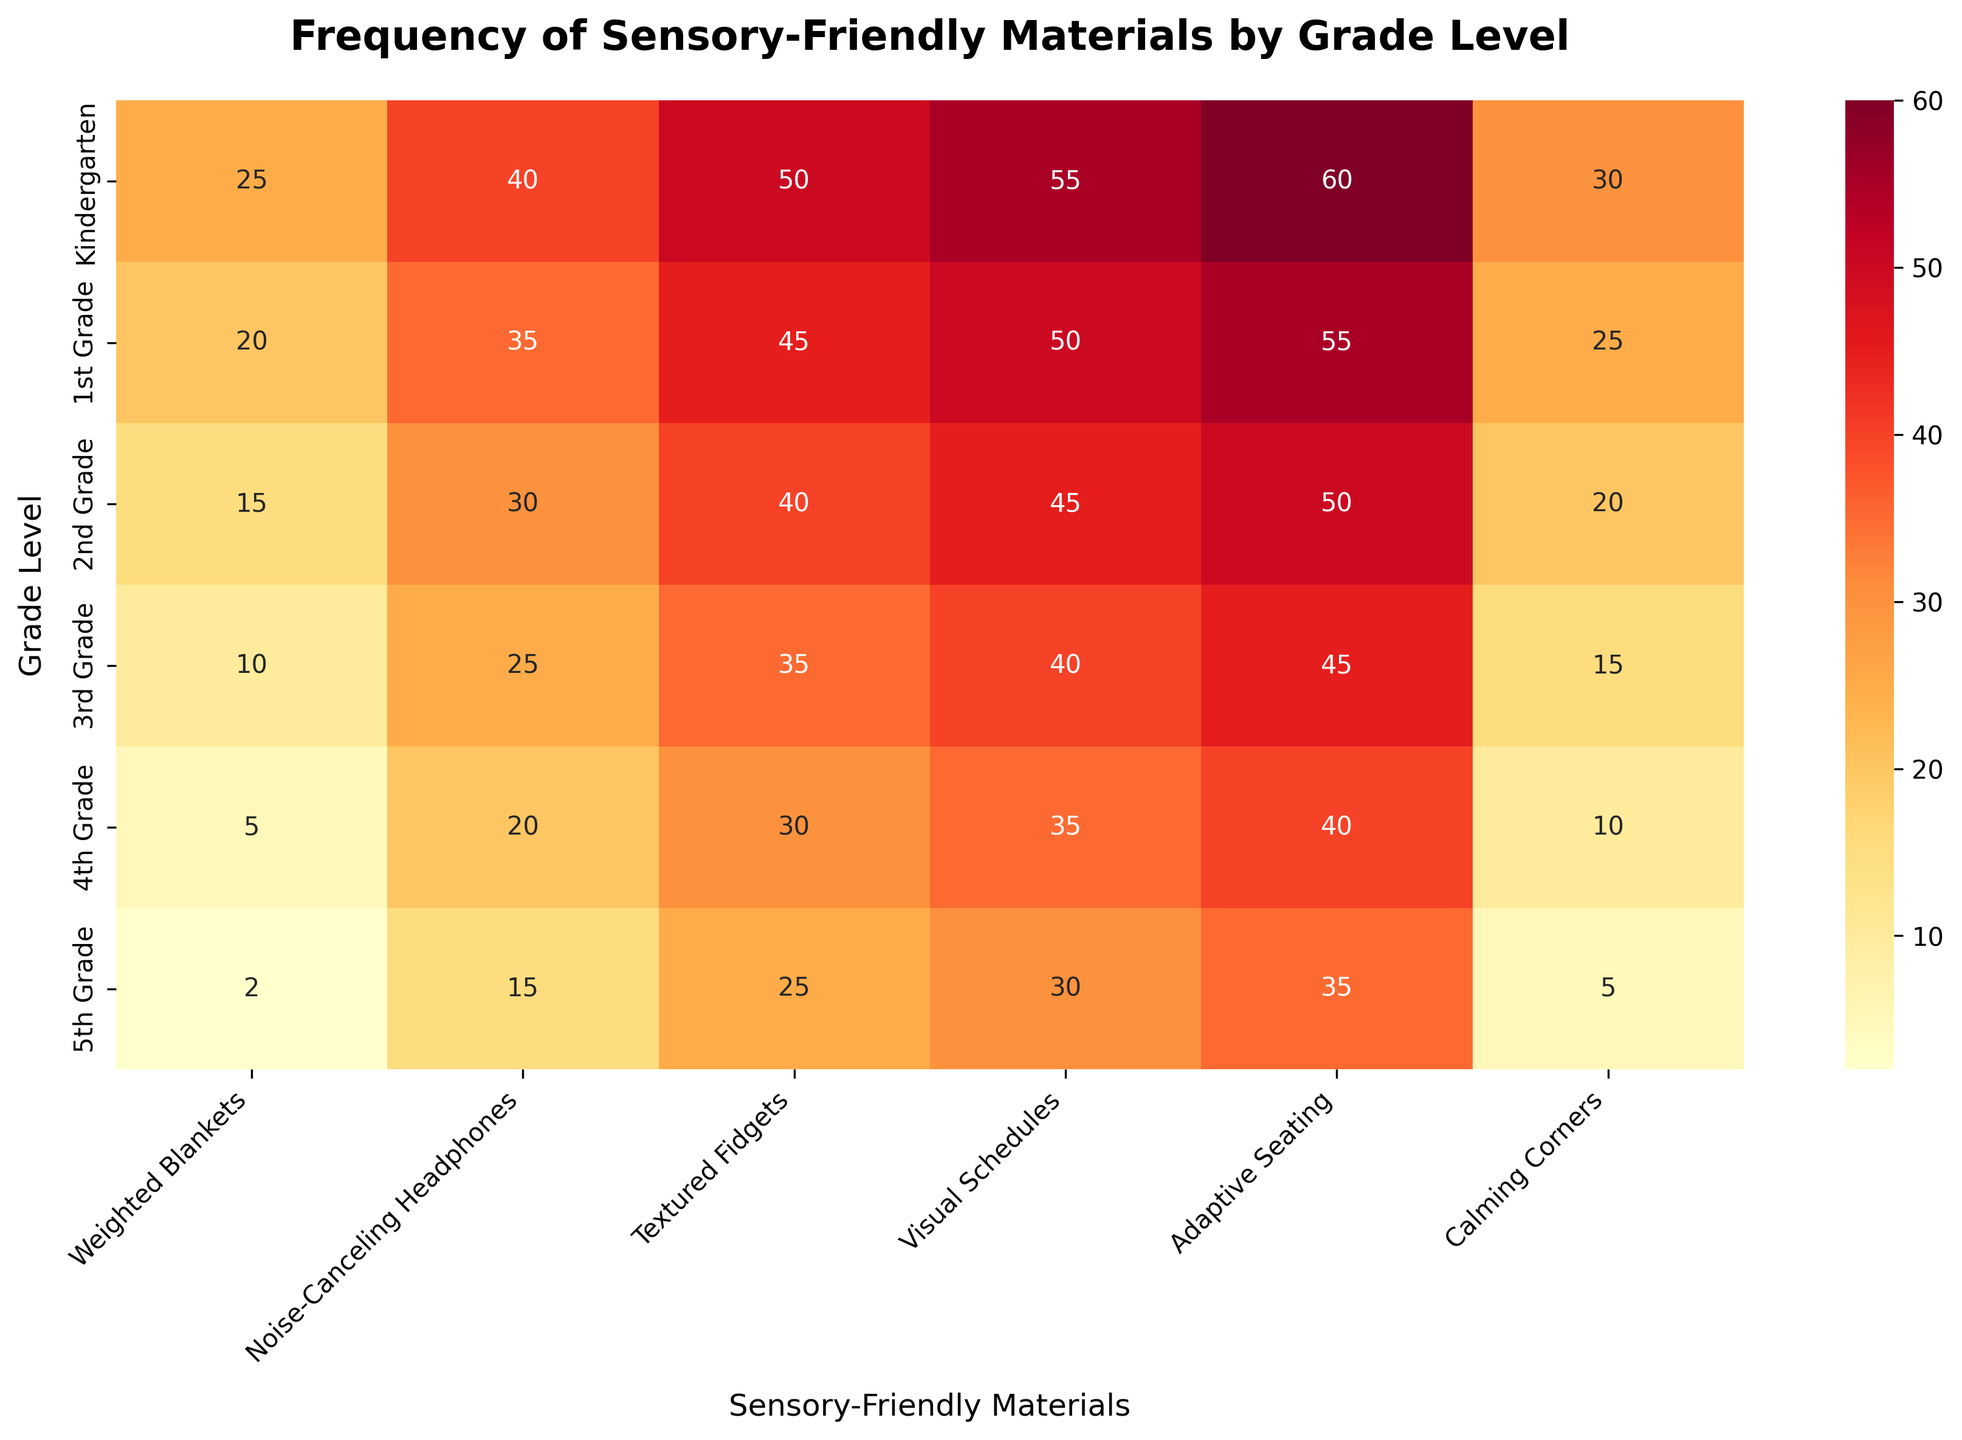What is the title of the figure? The title is located at the top of the heatmap and it is in a larger, bold font. It provides an overview of what the heatmap displays.
Answer: Frequency of Sensory-Friendly Materials by Grade Level Which sensory-friendly material is used most frequently in Kindergarten? Look at the first row labeled "Kindergarten" and find the highest value among the columns representing different materials.
Answer: Adaptive Seating What is the combined frequency of Textured Fidgets and Visual Schedules for 1st Grade? Identify the values for Textured Fidgets and Visual Schedules in the 1st Grade row, then add them together: 45 (Textured Fidgets) + 50 (Visual Schedules) = 95.
Answer: 95 Which grade level uses Noise-Canceling Headphones the least? Look down the column for Noise-Canceling Headphones and find the smallest value, then trace it back to the corresponding grade level.
Answer: 5th Grade Is the use of Calming Corners increasing or decreasing as the grade level increases? Observe the values in the Calming Corners column from Kindergarten to 5th Grade. Notice the trend of the values decreasing: 30, 25, 20, 15, 10, 5.
Answer: Decreasing Which material shows the greatest reduction in use between Kindergarten and 5th Grade? Compare the values for each material between Kindergarten and 5th Grade, noting the difference: Weighted Blankets (23), Noise-Canceling Headphones (25), Textured Fidgets (25), Visual Schedules (25), Adaptive Seating (25), Calming Corners (25); the greatest reduction is for all except Weighted Blankets.
Answer: Noise-Canceling Headphones, Textured Fidgets, Visual Schedules, Adaptive Seating, Calming Corners What is the frequency range (difference between maximum and minimum) of Adaptive Seating across all grade levels? Identify the highest and lowest values in the Adaptive Seating column: 60 (Kindergarten), 35 (5th Grade), then compute the range: 60 - 35 = 25.
Answer: 25 Which grade level has the highest frequency of Weighted Blankets? Look at the column for Weighted Blankets and find the highest value, then trace it back to the corresponding grade level.
Answer: Kindergarten Compare the frequency of Visual Schedules and Weighted Blankets for 3rd Grade. Which one is more frequently used? Look at the row for 3rd Grade and compare the values for Visual Schedules (40) and Weighted Blankets (10).
Answer: Visual Schedules How many materials are used more than 20 times in 4th Grade? Check the values in the row for 4th Grade and count how many are greater than 20: Noise-Canceling Headphones (20) is not greater, but Textured Fidgets (30), Visual Schedules (35), and Adaptive Seating (40) are.
Answer: 3 